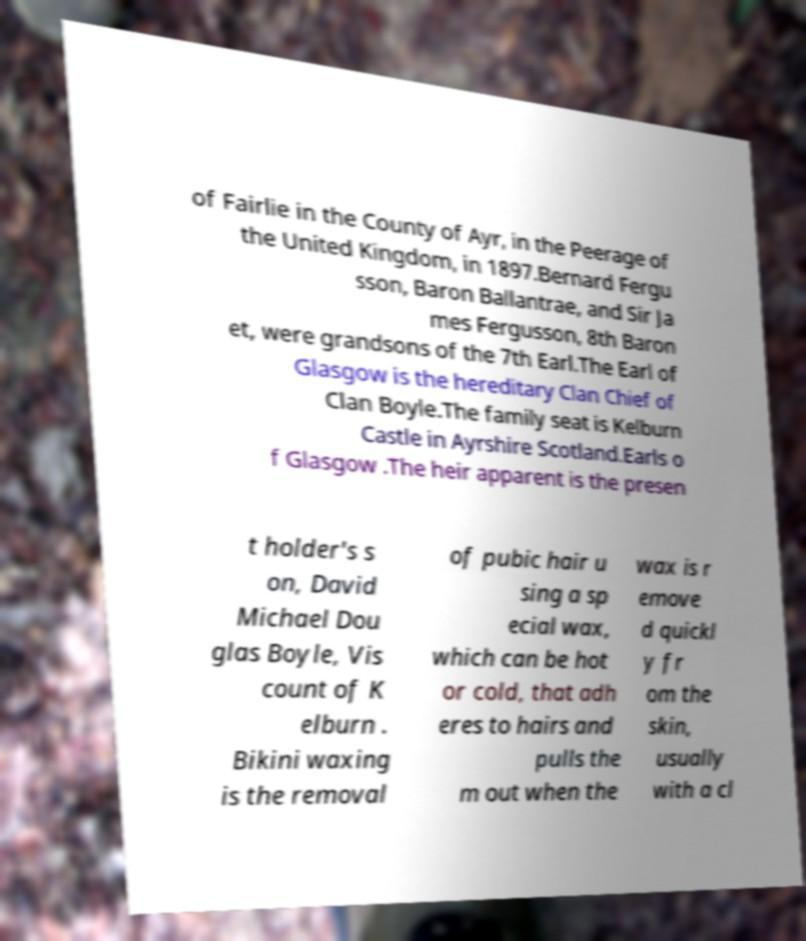What messages or text are displayed in this image? I need them in a readable, typed format. of Fairlie in the County of Ayr, in the Peerage of the United Kingdom, in 1897.Bernard Fergu sson, Baron Ballantrae, and Sir Ja mes Fergusson, 8th Baron et, were grandsons of the 7th Earl.The Earl of Glasgow is the hereditary Clan Chief of Clan Boyle.The family seat is Kelburn Castle in Ayrshire Scotland.Earls o f Glasgow .The heir apparent is the presen t holder's s on, David Michael Dou glas Boyle, Vis count of K elburn . Bikini waxing is the removal of pubic hair u sing a sp ecial wax, which can be hot or cold, that adh eres to hairs and pulls the m out when the wax is r emove d quickl y fr om the skin, usually with a cl 